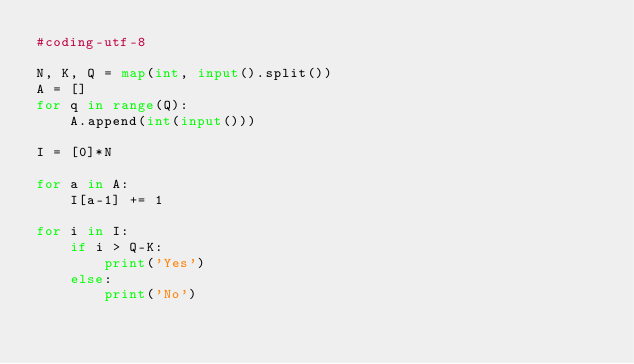Convert code to text. <code><loc_0><loc_0><loc_500><loc_500><_Python_>#coding-utf-8

N, K, Q = map(int, input().split())
A = []
for q in range(Q):
    A.append(int(input()))

I = [0]*N

for a in A:
    I[a-1] += 1

for i in I:
    if i > Q-K:
        print('Yes')
    else:
        print('No')
</code> 